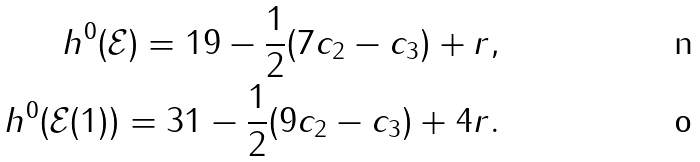<formula> <loc_0><loc_0><loc_500><loc_500>h ^ { 0 } ( \mathcal { E } ) = 1 9 - \frac { 1 } { 2 } ( 7 c _ { 2 } - c _ { 3 } ) + r , \\ h ^ { 0 } ( \mathcal { E } ( 1 ) ) = 3 1 - \frac { 1 } { 2 } ( 9 c _ { 2 } - c _ { 3 } ) + 4 r .</formula> 